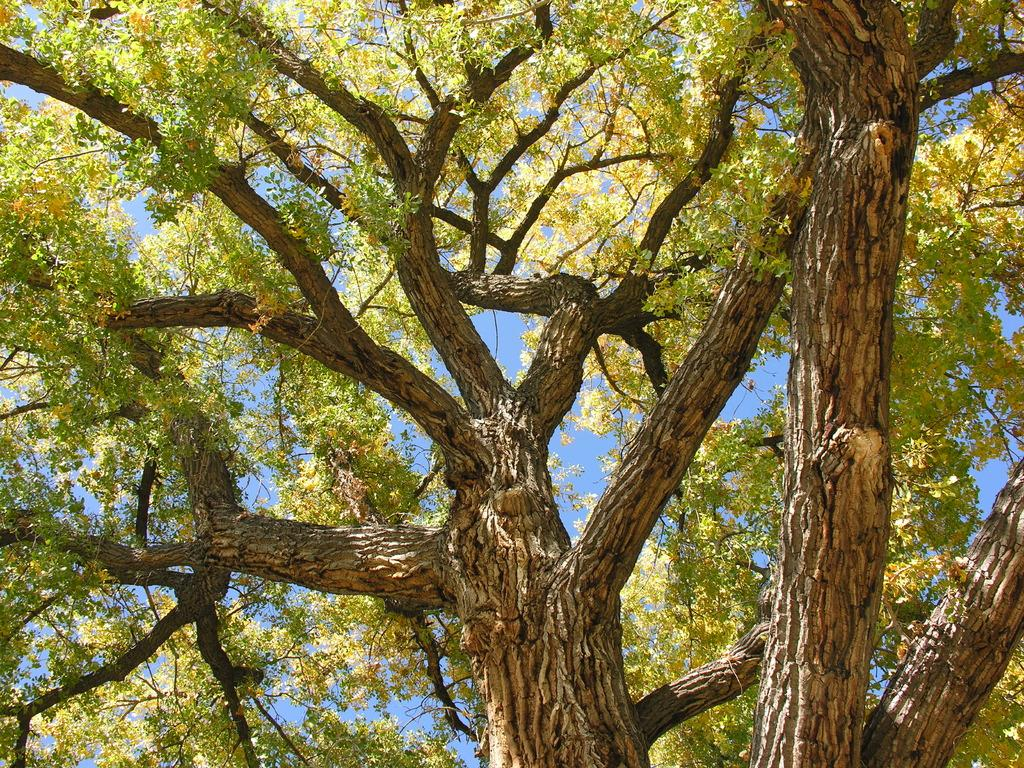What is the main feature in the center of the image? The center of the image contains the sky. What type of plant can be seen in the image? There is a tree with multiple branches in the image. What type of disease is affecting the tree in the image? There is no indication of any disease affecting the tree in the image. What is the color of the chin of the person in the image? There is no person present in the image, so there is no chin to observe. 